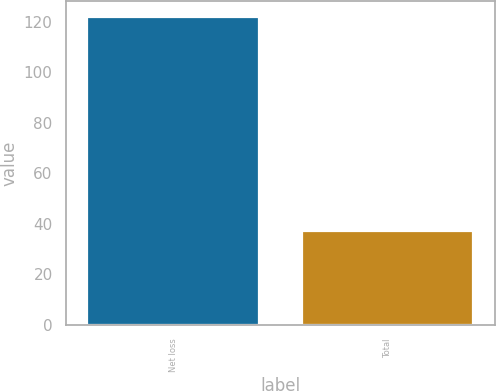Convert chart. <chart><loc_0><loc_0><loc_500><loc_500><bar_chart><fcel>Net loss<fcel>Total<nl><fcel>122<fcel>37<nl></chart> 